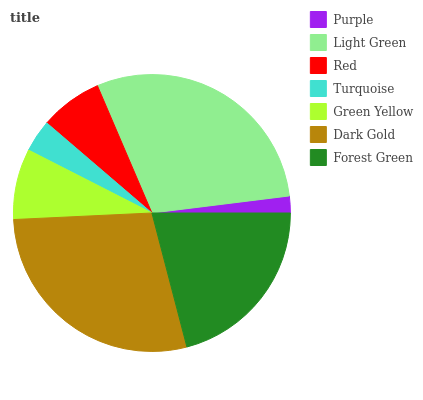Is Purple the minimum?
Answer yes or no. Yes. Is Light Green the maximum?
Answer yes or no. Yes. Is Red the minimum?
Answer yes or no. No. Is Red the maximum?
Answer yes or no. No. Is Light Green greater than Red?
Answer yes or no. Yes. Is Red less than Light Green?
Answer yes or no. Yes. Is Red greater than Light Green?
Answer yes or no. No. Is Light Green less than Red?
Answer yes or no. No. Is Green Yellow the high median?
Answer yes or no. Yes. Is Green Yellow the low median?
Answer yes or no. Yes. Is Purple the high median?
Answer yes or no. No. Is Purple the low median?
Answer yes or no. No. 